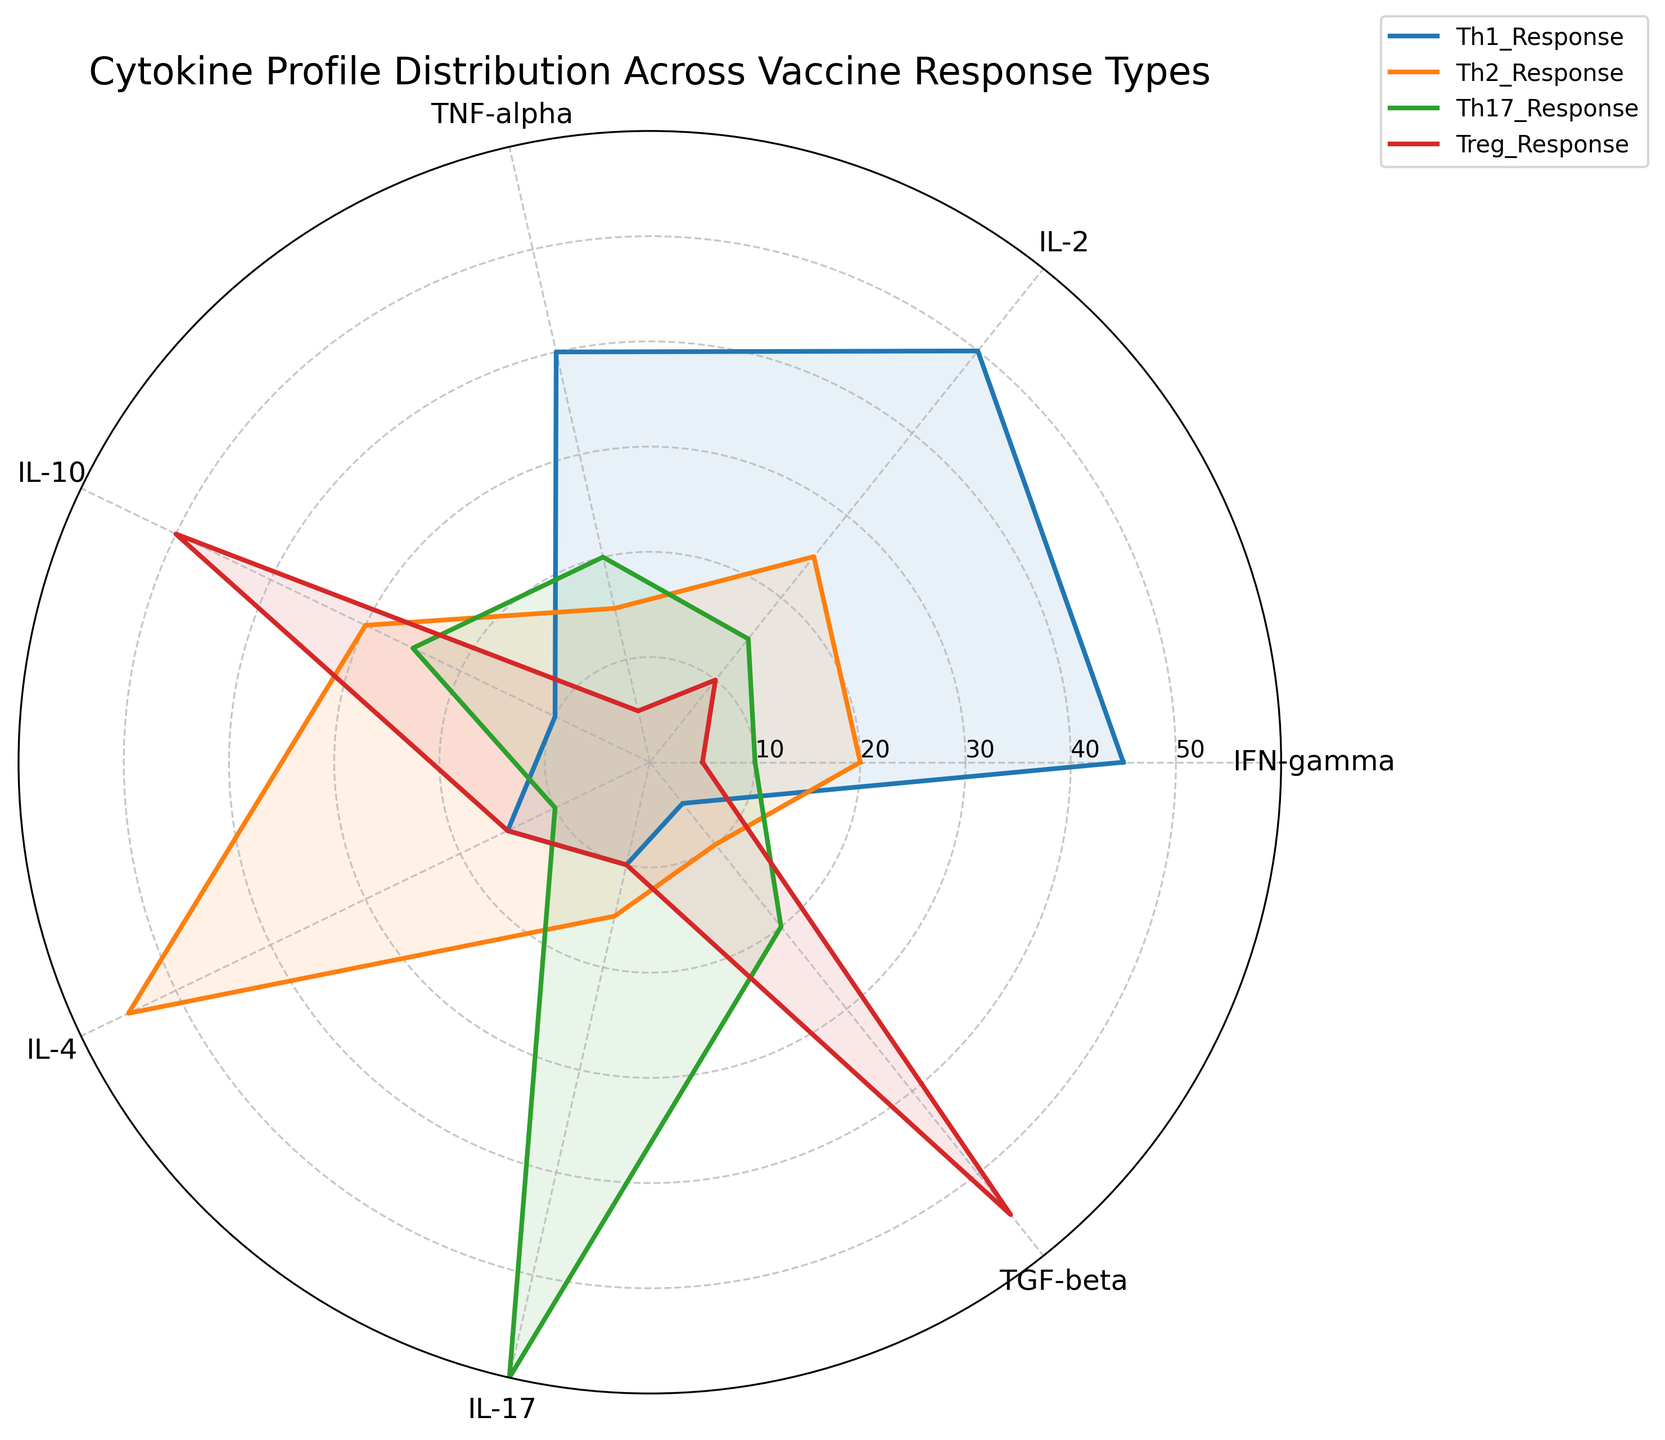What's the title of the radar chart? The title of the radar chart is "Cytokine Profile Distribution Across Vaccine Response Types." This is explicitly mentioned at the top of the figure.
Answer: Cytokine Profile Distribution Across Vaccine Response Types How many cytokines are plotted in the radar chart? There are seven cytokines plotted in the radar chart. These are given as labels for each axis.
Answer: Seven Which vaccine response type shows the highest value for IL-4? The radar chart shows that the Th2_Response has the highest value for IL-4, compared to the other types of responses.
Answer: Th2_Response What is the range of the radial axis in the chart? The radial axis in the chart ranges from 0 to 60, as indicated by the y-axis tick labels and the grid.
Answer: 0 to 60 Which Vaccine Response Type has the lowest value for IFN-gamma? The radar chart shows that the Treg_Response has the lowest value for IFN-gamma.
Answer: Treg_Response Which cytokine has a 55 value for the Treg_Response? The cytokine TGF-beta has a value of 55 for the Treg_Response, as indicated by the plot lines and labels.
Answer: TGF-beta Which vaccine response type shows the most balanced distribution across all cytokines? The Th1_Response shows the most balanced distribution across all cytokines, with values ranging more evenly compared to the other response types.
Answer: Th1_Response Which two cytokines have identical values for the Th1_Response? Both IL-10 and IL-17 have a value of 10 for the Th1_Response, as indicated by the labels and plot lines for the Th1_Response.
Answer: IL-10 and IL-17 How does the IL-2 response for Th2_Response compare to that of Th1_Response? The IL-2 response for Th2_Response is 25, which is half of the IL-2 response for Th1_Response, which is 50. This can be seen on the radar chart by comparing their respective plot lines.
Answer: Th2 is half of Th1 What is the average value of IL-17 across all vaccine response types? The values of IL-17 across all vaccine response types are: 10 (Th1_Response), 15 (Th2_Response), 60 (Th17_Response), and 10 (Treg_Response). Summing these values gives 95, and dividing by the number of response types (4) gives an average value of 23.75.
Answer: 23.75 